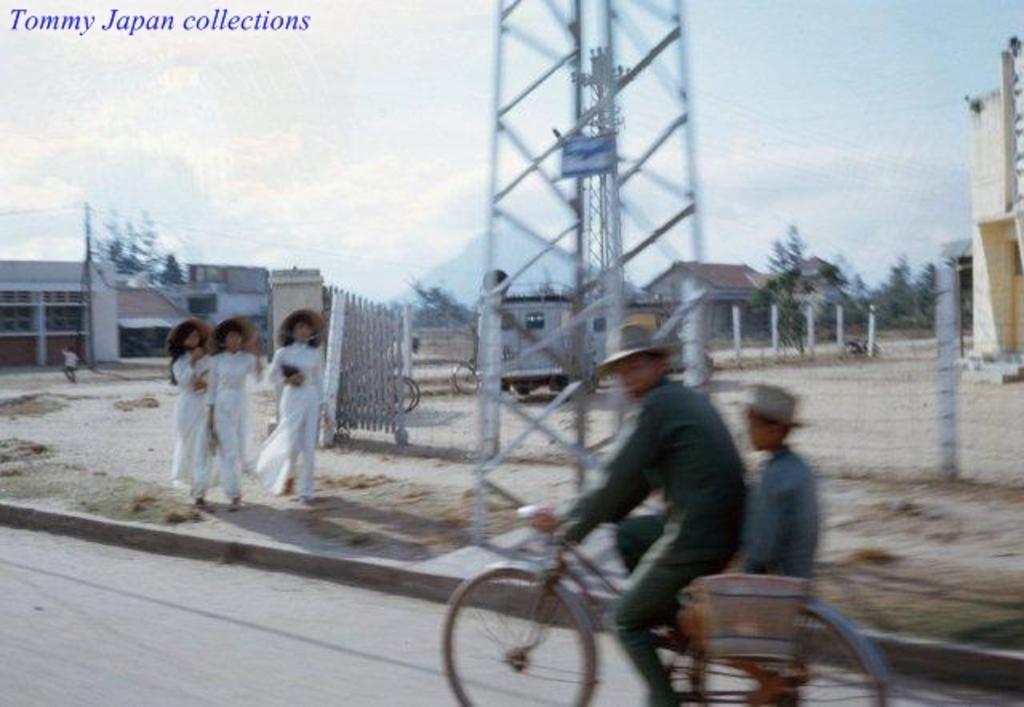In one or two sentences, can you explain what this image depicts? this picture shows a man riding a bicycle and we see three people walking on the sidewalk and we see few houses and few trees 